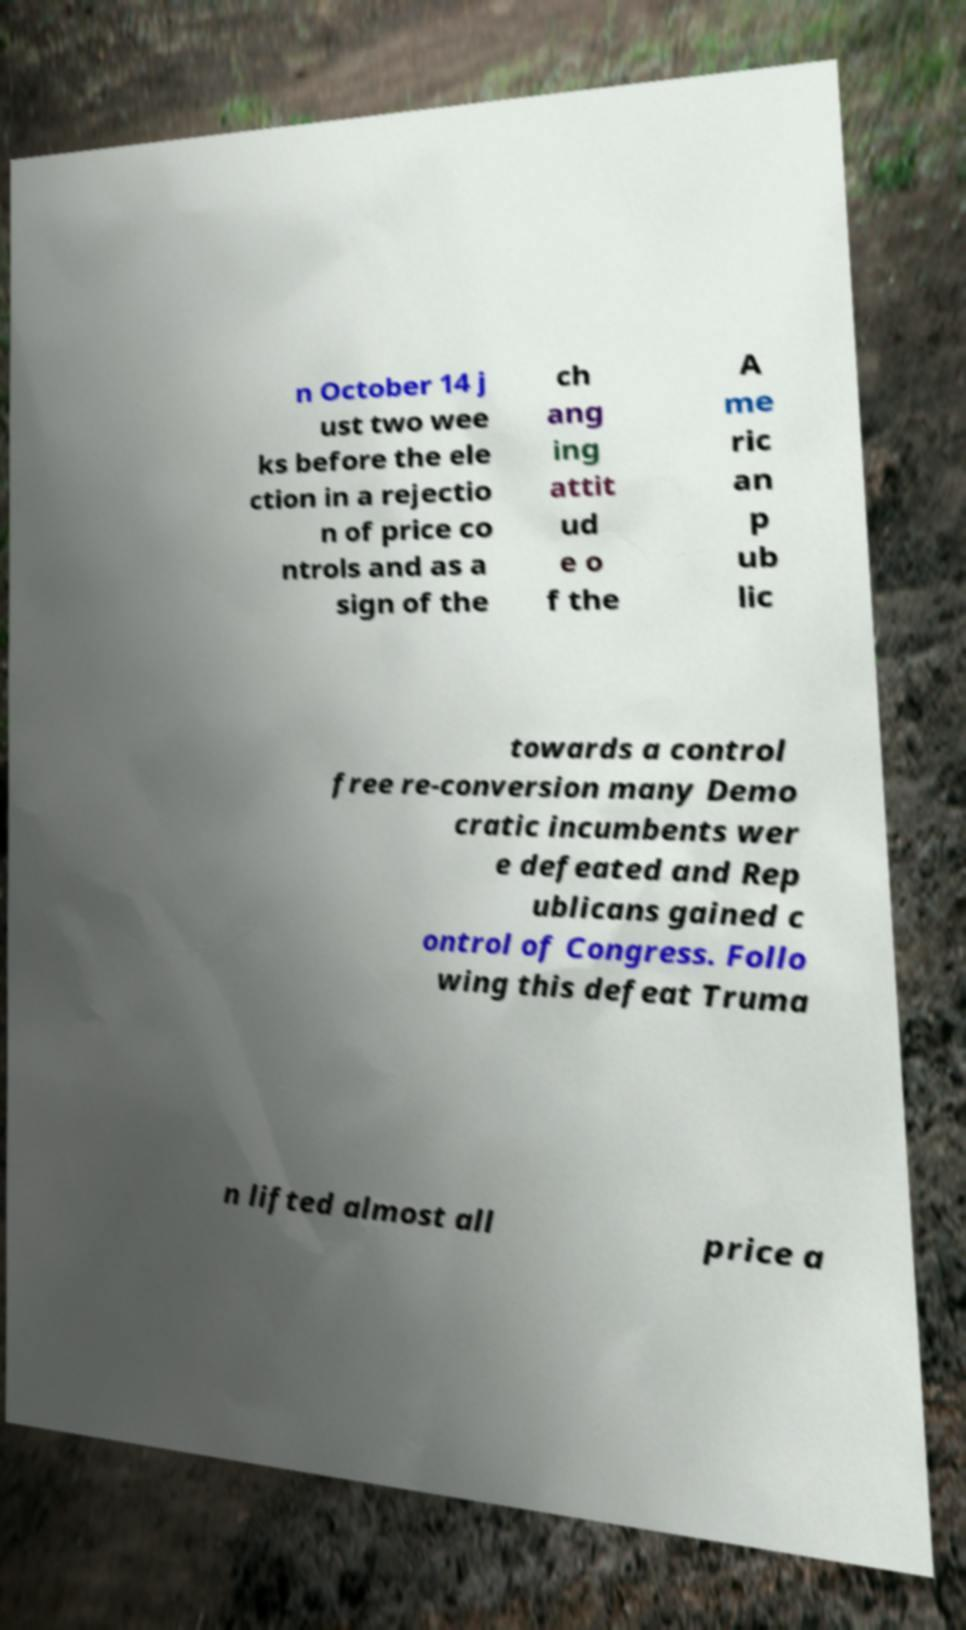For documentation purposes, I need the text within this image transcribed. Could you provide that? n October 14 j ust two wee ks before the ele ction in a rejectio n of price co ntrols and as a sign of the ch ang ing attit ud e o f the A me ric an p ub lic towards a control free re-conversion many Demo cratic incumbents wer e defeated and Rep ublicans gained c ontrol of Congress. Follo wing this defeat Truma n lifted almost all price a 